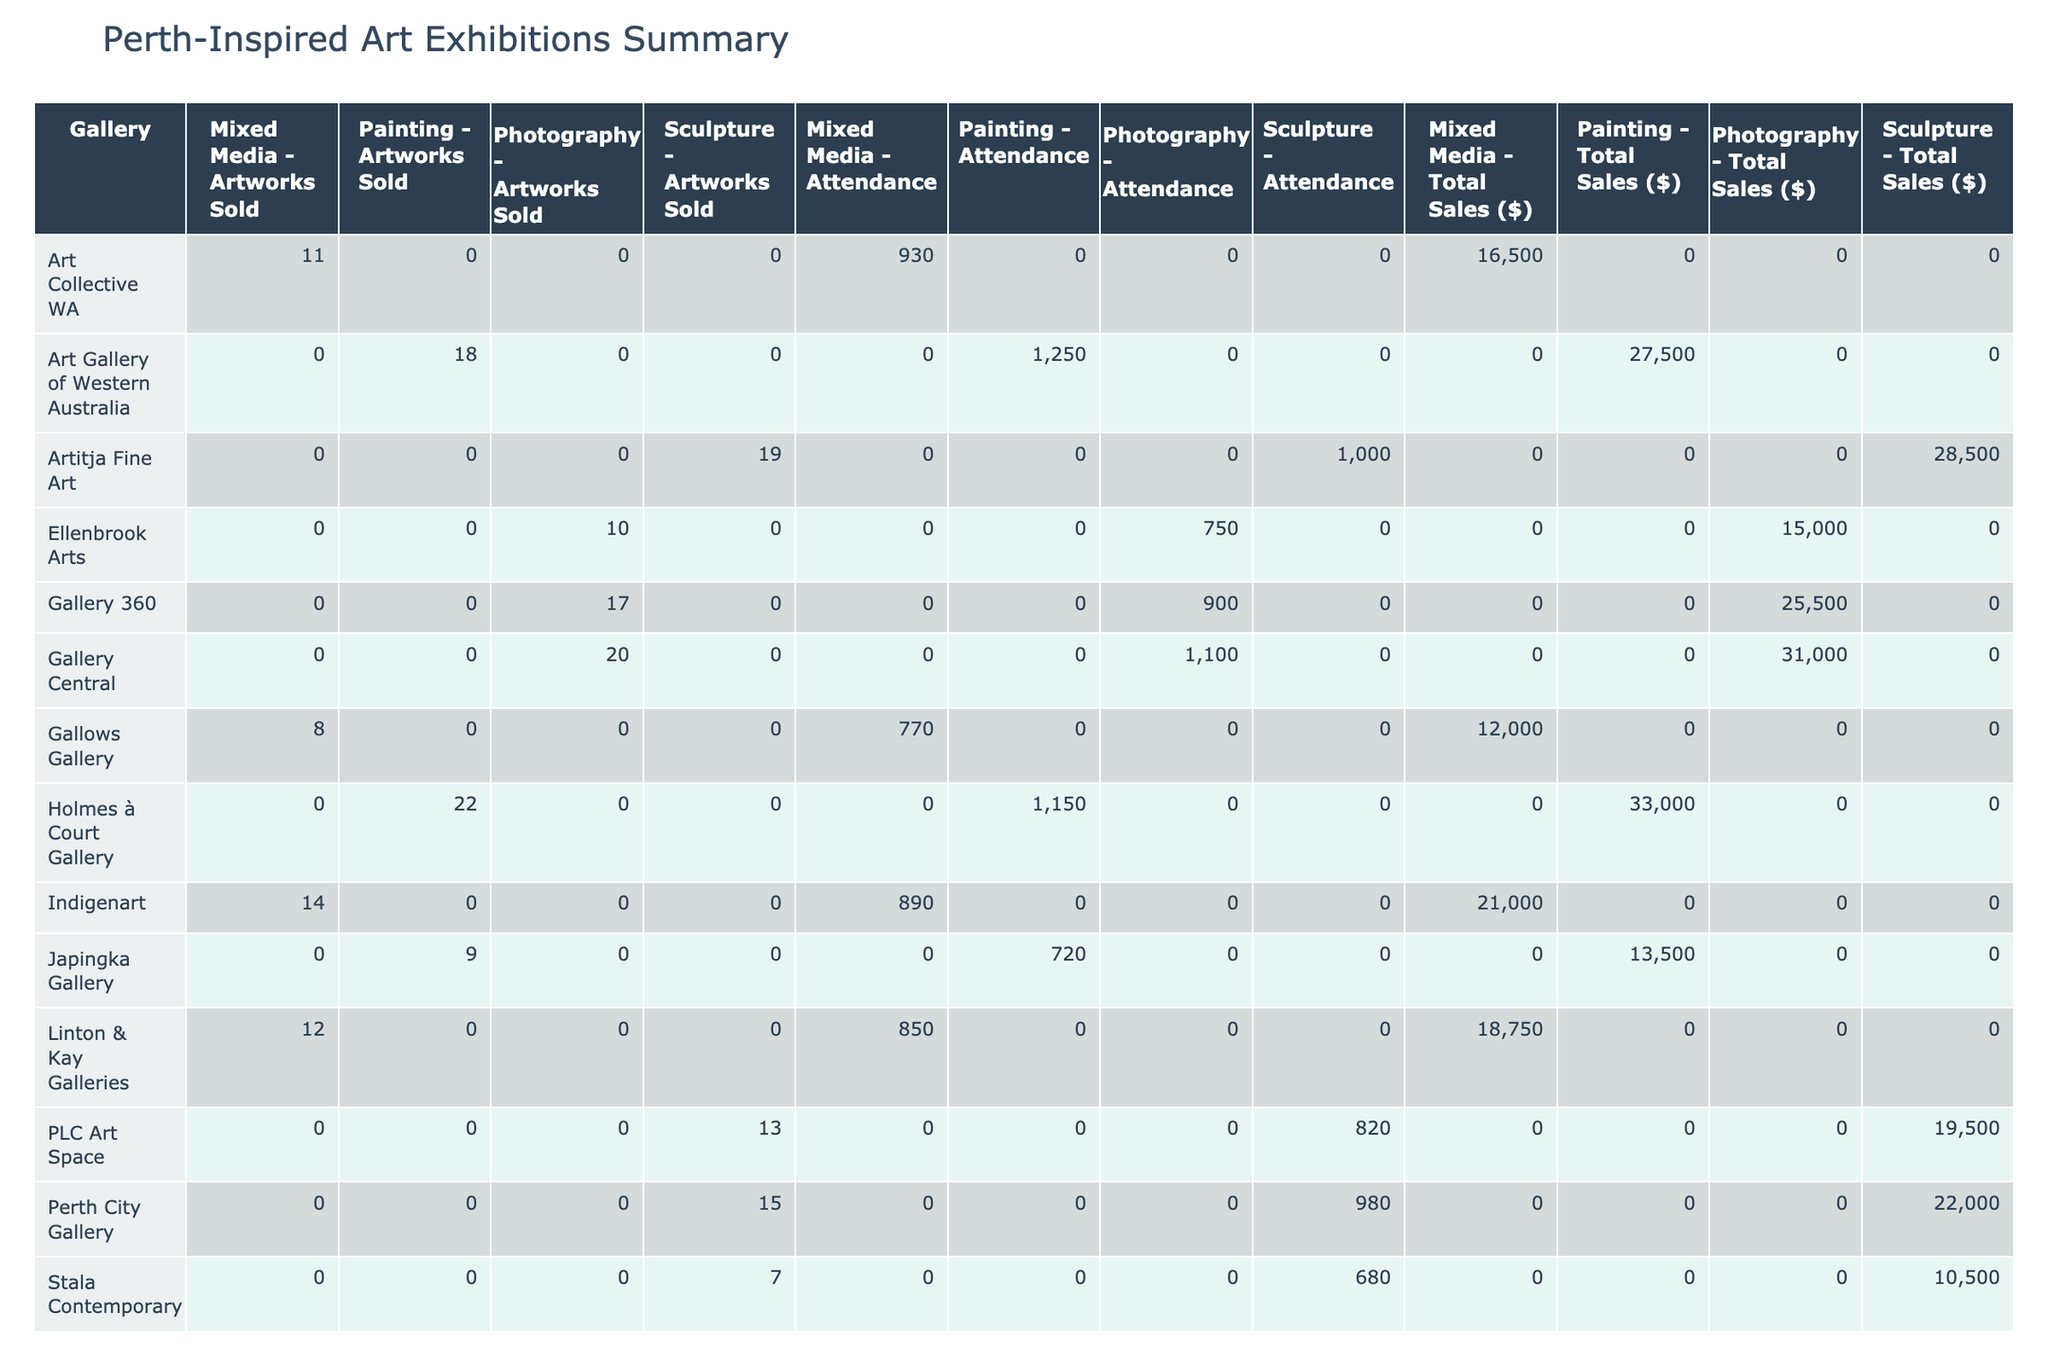What is the total attendance across all exhibitions? To find the total attendance, we can sum the Attendance column for each gallery. The total attendance is calculated as follows: 1250 + 850 + 980 + 720 + 1100 + 890 + 680 + 1050 + 930 + 750 + 820 + 1150 + 770 + 900 + 1000 = 13950.
Answer: 13950 Which gallery had the highest total sales? To determine which gallery had the highest total sales, we can look at the Total Sales ($) column. The highest value is 33000 from Holmes à Court Gallery.
Answer: Holmes à Court Gallery How many artworks were sold in total at the Art Gallery of Western Australia? We can directly refer to the Artworks Sold column for the Art Gallery of Western Australia, which shows a value of 18.
Answer: 18 What is the average number of artworks sold per exhibition in the table? To calculate the average artworks sold, we first sum the Artworks Sold column: 18 + 12 + 15 + 9 + 20 + 14 + 7 + 16 + 11 + 10 + 13 + 22 + 8 + 17 + 19 =  16. The total number of exhibitions is 15, so the average is 16/15 = 1.07.
Answer: 1.07 Is the statement "Photography artworks sold more than Painting artworks" true based on the table? To verify this, we check the totals for Photography and Painting in the Artworks Sold column. Photography (20 + 10 + 17) = 47 and Painting (18 + 9 + 16 + 22) = 65. Since 47 is not greater than 65, the statement is false.
Answer: False What percentage of artworks sold at Gallery Central were photography? First, we find the number of artworks sold at Gallery Central for photography, which is 20. Then, we find the total artworks sold at Gallery Central: 20 (Photography). The percentage is calculated as (20/20) * 100 = 100%.
Answer: 100% Which artwork type had the least attendance across all exhibitions? To find the least attendance per artwork type, we need to calculate the total attendance for each type: Painting (1250 + 720 + 1050 + 1150 = 3170), Mixed Media (850 + 14 + 8 = 1870), Sculpture (980 + 15 + 680 + 16 + 13 + 19 = 2851), and Photography (1100 + 10 + 17 = 1127). The least is Mixed Media with 1870.
Answer: Mixed Media Which gallery had the second highest artwork sales and what was the amount? We check the Total Sales ($) column to rank total sales and find the second highest. The order is: 33000 (Holmes à Court Gallery) and 31000 (Gallery Central), so the second highest is Gallery Central with 31000.
Answer: Gallery Central, 31000 How many galleries had an attendance exceeding 1000? We can look for exhibition entries with attendance values exceeding 1000. The galleries with attendance exceeding 1000 are: Art Gallery of Western Australia (1250), Gallery Central (1100), and Holmes à Court Gallery (1150). Thus, there are 3 galleries.
Answer: 3 